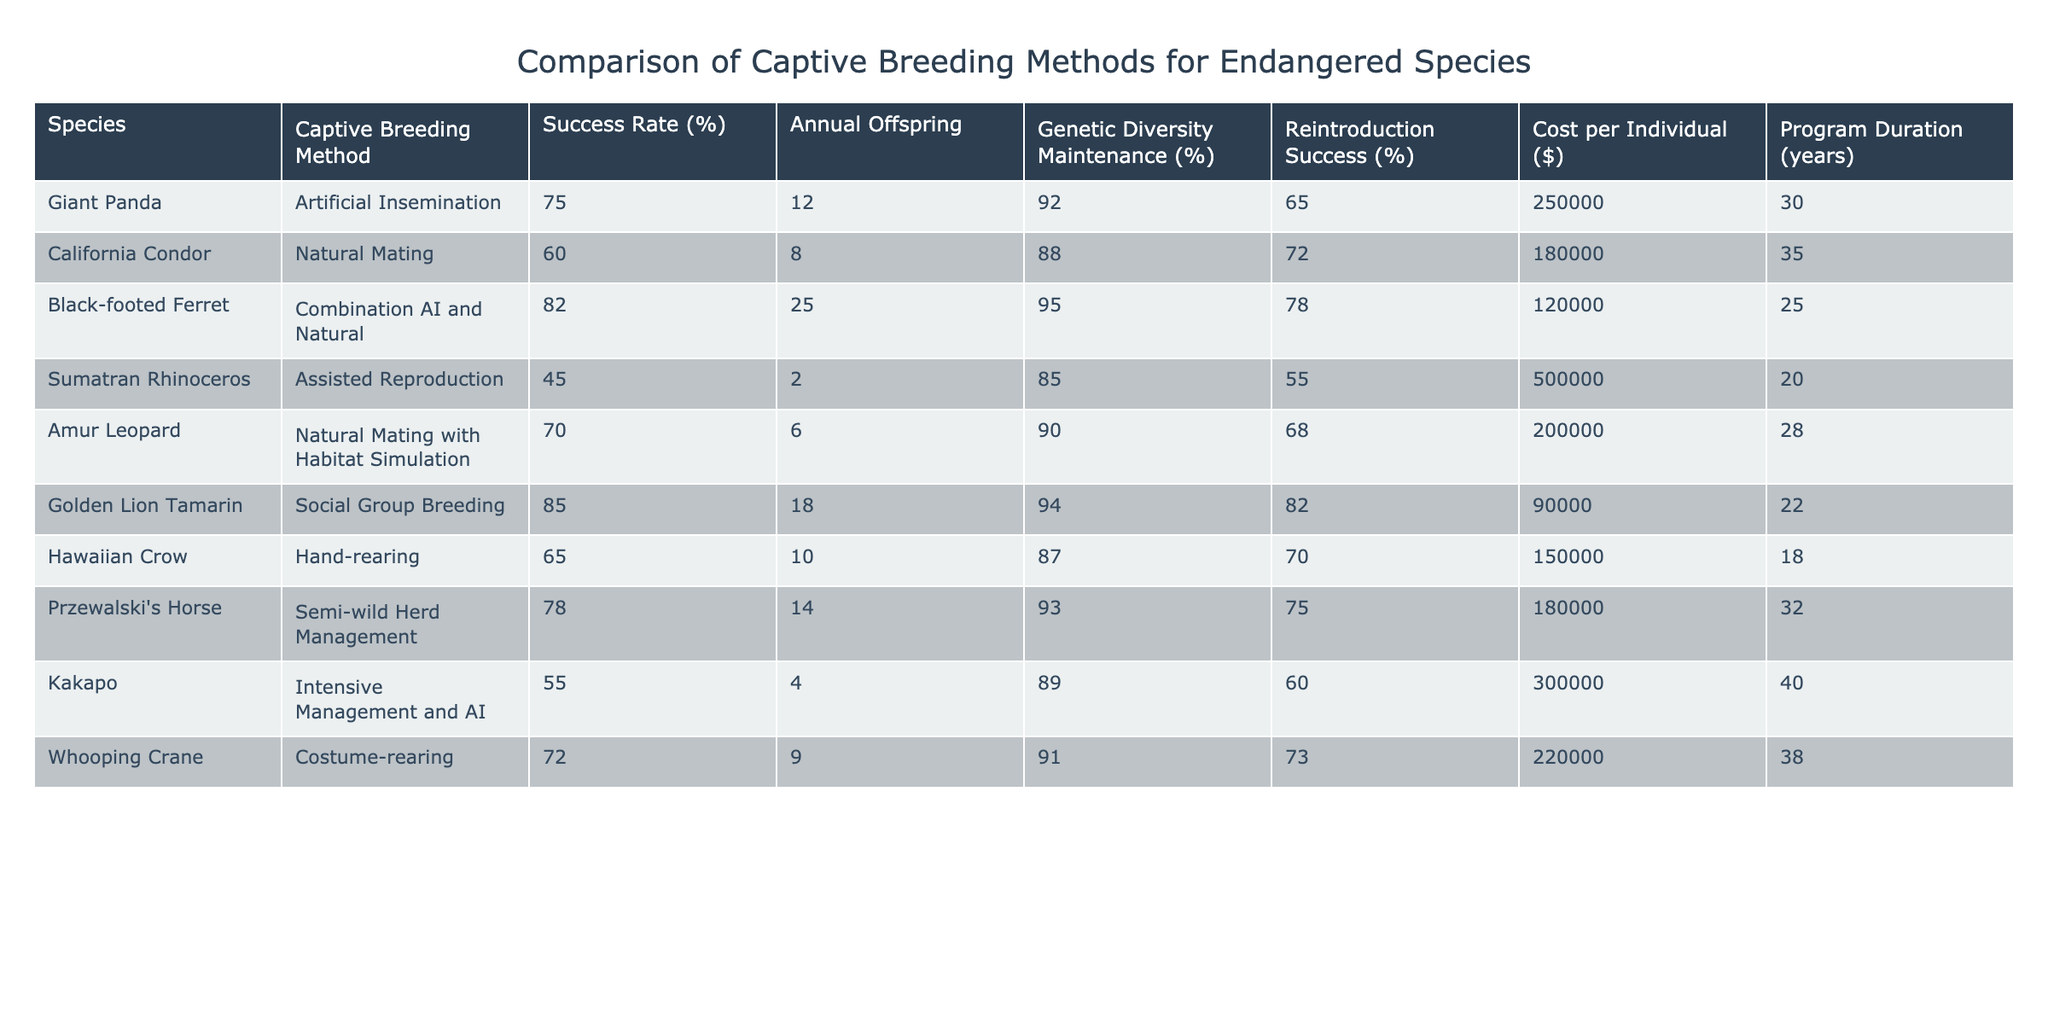What is the success rate of artificial insemination for the Giant Panda? The table lists the success rate for the Giant Panda under the "Success Rate (%)" column as 75%.
Answer: 75% Which captive breeding method for the Golden Lion Tamarin has the highest genetic diversity maintenance percentage? The table shows that the Golden Lion Tamarin has a genetic diversity maintenance percentage of 94%, which is the highest among the listed methods.
Answer: 94% What is the cost per individual for the Sumatran Rhinoceros breeding program? The table indicates the cost per individual for the Sumatran Rhinoceros as $500,000.
Answer: 500000 How many annual offspring are produced on average by the species that use artificial insemination? The species that use artificial insemination are the Giant Panda and Kakapo, producing 12 and 4 annual offspring respectively. The average is (12 + 4)/2 = 8.
Answer: 8 Is the reintroduction success rate for the California Condor higher than that for the Hawaiian Crow? The table shows the reintroduction success rate for the California Condor at 88% and the Hawaiian Crow at 87%. Since 88% is higher than 87%, the statement is true.
Answer: Yes For which species is the combination of artificial insemination and natural mating the most effective method? The Black-footed Ferret uses a combination of AI and natural mating with a success rate of 82%, which is the highest success rate for this method, compared to others listed.
Answer: Black-footed Ferret What is the total annual offspring produced by all species utilizing natural mating methods? The species that use natural mating methods are California Condor (8), Amur Leopard (6), and those using semi-wild and social methods that contribute (no others specified in the data here). The total is 8 + 6 = 14.
Answer: 14 Identify a species that has a reintroduction success rate below 75%. The Sumatran Rhinoceros has a reintroduction success rate of 65%, which is below 75%.
Answer: Sumatran Rhinoceros What is the difference in success rates between the Black-footed Ferret's breeding method and the Sumatran Rhinoceros's breeding method? The Black-footed Ferret has a success rate of 82% and the Sumatran Rhinoceros has a success rate of 45%. The difference is 82 - 45 = 37.
Answer: 37 